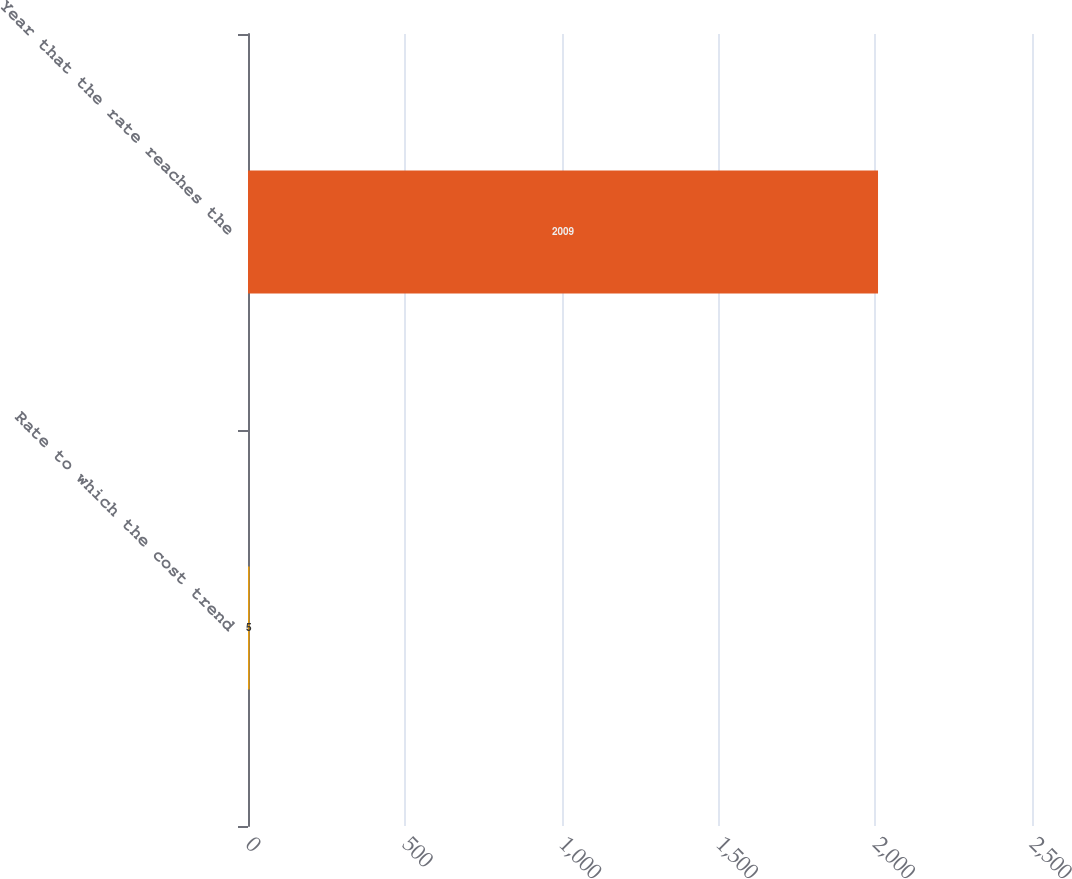<chart> <loc_0><loc_0><loc_500><loc_500><bar_chart><fcel>Rate to which the cost trend<fcel>Year that the rate reaches the<nl><fcel>5<fcel>2009<nl></chart> 